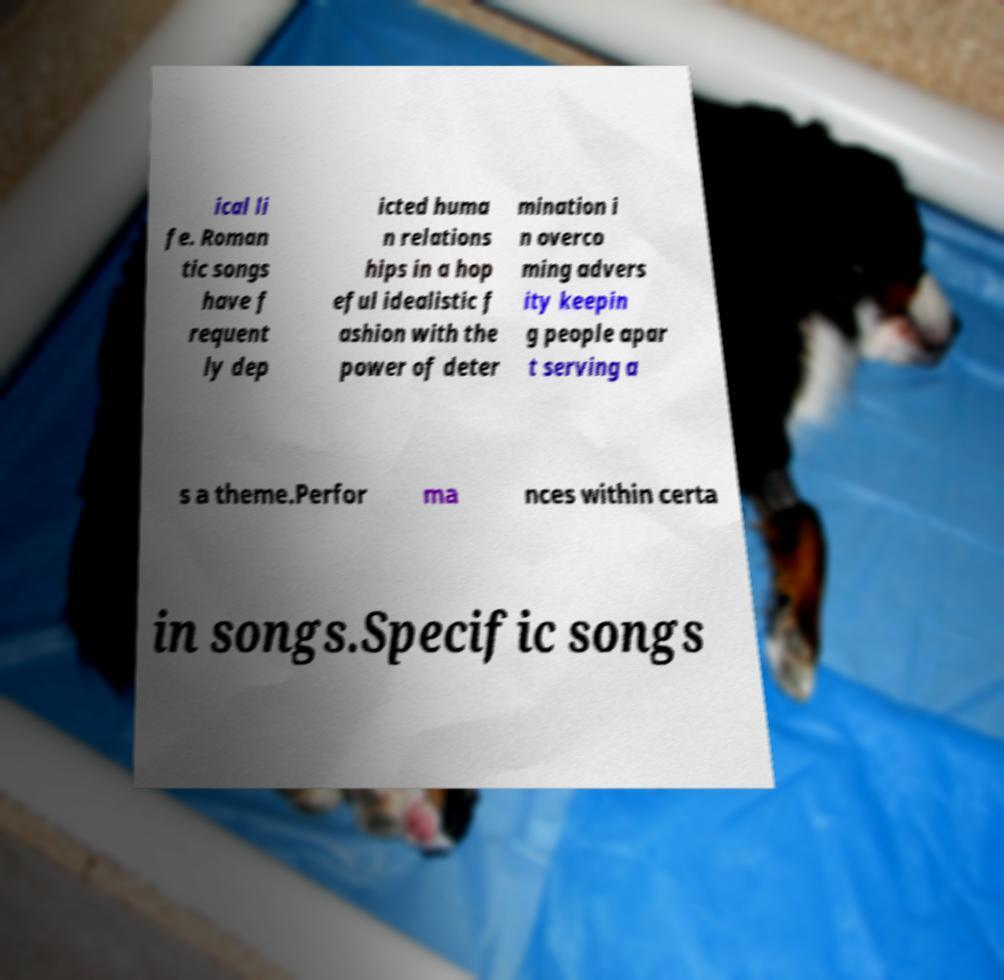There's text embedded in this image that I need extracted. Can you transcribe it verbatim? ical li fe. Roman tic songs have f requent ly dep icted huma n relations hips in a hop eful idealistic f ashion with the power of deter mination i n overco ming advers ity keepin g people apar t serving a s a theme.Perfor ma nces within certa in songs.Specific songs 